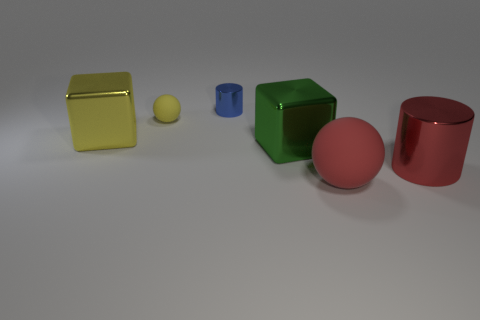Subtract all brown balls. Subtract all yellow cylinders. How many balls are left? 2 Add 2 cyan metallic cubes. How many objects exist? 8 Subtract all cylinders. How many objects are left? 4 Subtract 1 red cylinders. How many objects are left? 5 Subtract all large brown rubber things. Subtract all green shiny things. How many objects are left? 5 Add 2 red cylinders. How many red cylinders are left? 3 Add 3 large green metallic cylinders. How many large green metallic cylinders exist? 3 